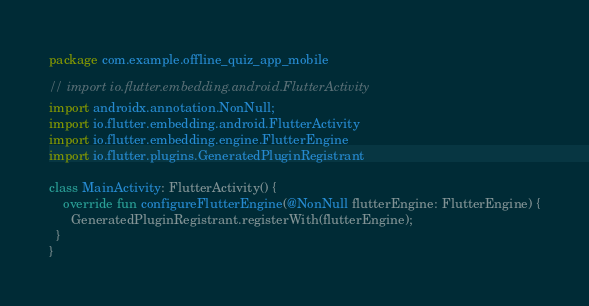<code> <loc_0><loc_0><loc_500><loc_500><_Kotlin_>package com.example.offline_quiz_app_mobile

// import io.flutter.embedding.android.FlutterActivity
import androidx.annotation.NonNull;
import io.flutter.embedding.android.FlutterActivity
import io.flutter.embedding.engine.FlutterEngine
import io.flutter.plugins.GeneratedPluginRegistrant

class MainActivity: FlutterActivity() {
    override fun configureFlutterEngine(@NonNull flutterEngine: FlutterEngine) {
      GeneratedPluginRegistrant.registerWith(flutterEngine);
  }
}</code> 